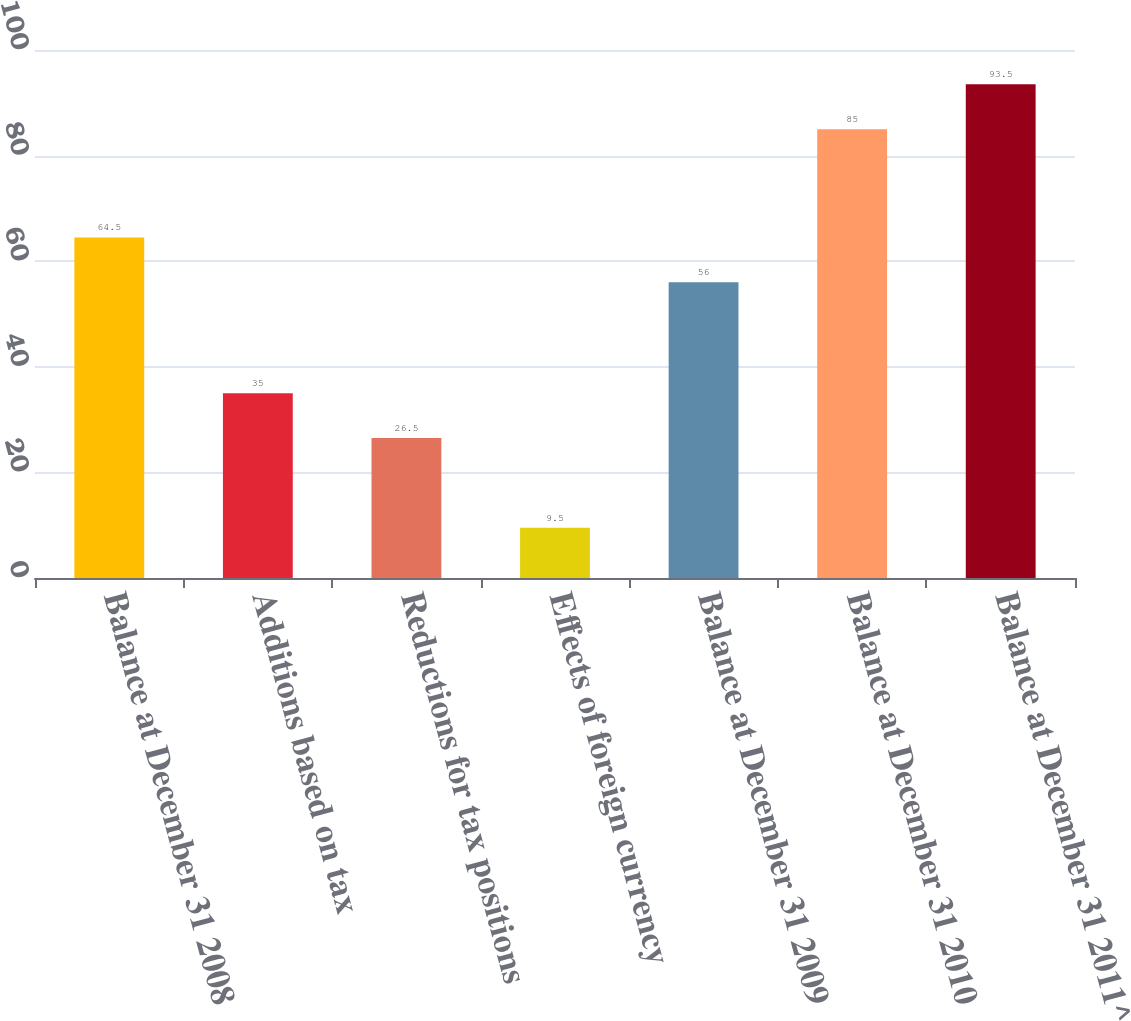Convert chart. <chart><loc_0><loc_0><loc_500><loc_500><bar_chart><fcel>Balance at December 31 2008<fcel>Additions based on tax<fcel>Reductions for tax positions<fcel>Effects of foreign currency<fcel>Balance at December 31 2009<fcel>Balance at December 31 2010<fcel>Balance at December 31 2011^<nl><fcel>64.5<fcel>35<fcel>26.5<fcel>9.5<fcel>56<fcel>85<fcel>93.5<nl></chart> 